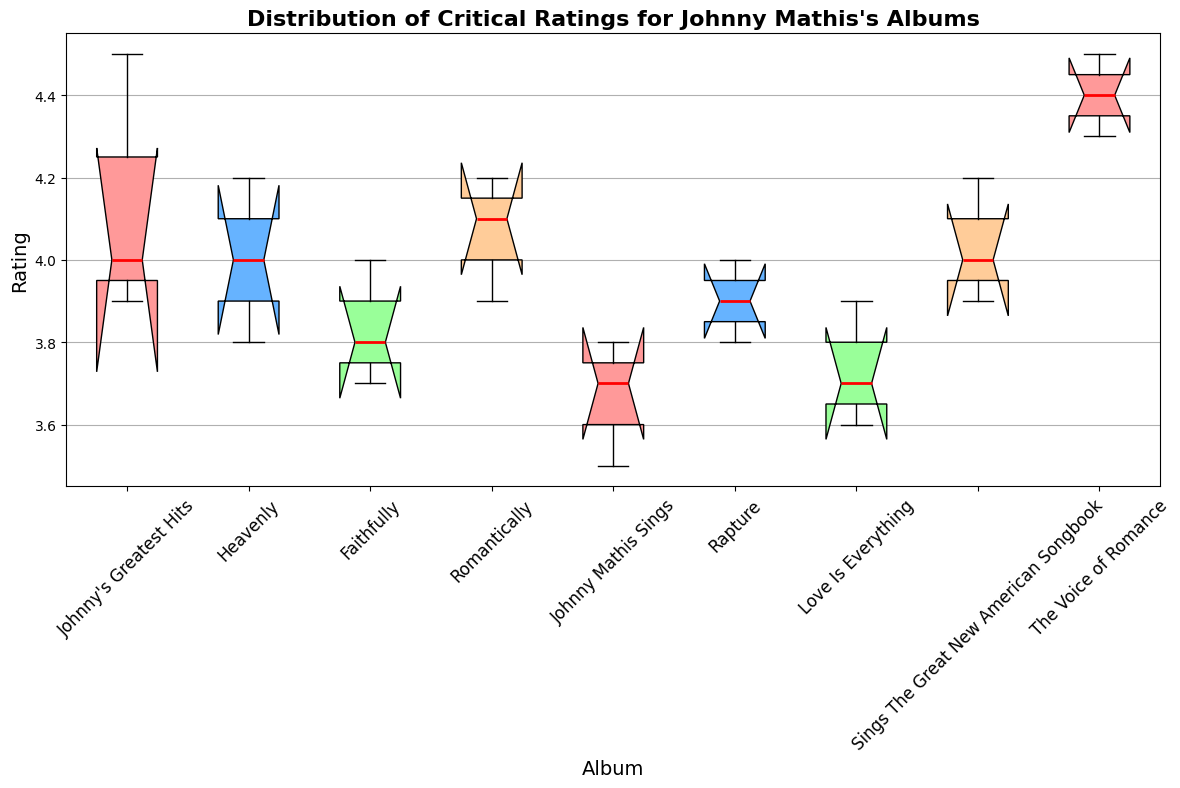Which album has the highest median rating? Evaluate the position of the red lines (medians) within each box plot. The highest median is for "The Voice of Romance".
Answer: The Voice of Romance Which album has the widest interquartile range (IQR)? Observe the box (representing the IQR) of each album. The album with the widest box is "The Voice of Romance".
Answer: The Voice of Romance How does the rating distribution for "Heavenly" compare to "Johnny's Greatest Hits"? Compare the boxes and whiskers of "Heavenly" and "Johnny's Greatest Hits". The "Heavenly" ratings are more tightly clustered with a lower median.
Answer: "Heavenly" has a lower median and a tighter rating distribution compared to "Johnny's Greatest Hits" Which album has the smallest range of ratings? Look at the length of the whiskers for each album. The smallest range is for "Faithfully".
Answer: Faithfully Does "Sings The Great New American Songbook" have any outliers? Check for any data points outside the whiskers. In this case, there are no points outside the whiskers for "Sings The Great New American Songbook".
Answer: No Which album's median rating lies closest to 4.0? Identify the median lines (red lines) and see which one lies closest to the 4.0 mark on the y-axis. The album is "Rapture".
Answer: Rapture How many albums have a median rating above 4.0? Count the albums where the red line (median) is above the 4.0 mark. There are five such albums: "Johnny's Greatest Hits", "Romantically", "Sings The Great New American Songbook", "The Voice of Romance", and "Rapture".
Answer: Five Which album has the most consistent (less variable) ratings? Determine which box plot is the narrowest, representing the least variation. The most consistent ratings are for "Faithfully".
Answer: Faithfully Which source provides the highest rating for "The Voice of Romance"? The source ratings are shown as different colors. The highest rating for "The Voice of Romance" is given by "Rolling Stone".
Answer: Rolling Stone Which source provides the lowest rating for "Johnny Mathis Sings"? Locate the minimum point within the "Johnny Mathis Sings" box plot. "AllMusic" gives the lowest rating.
Answer: AllMusic 